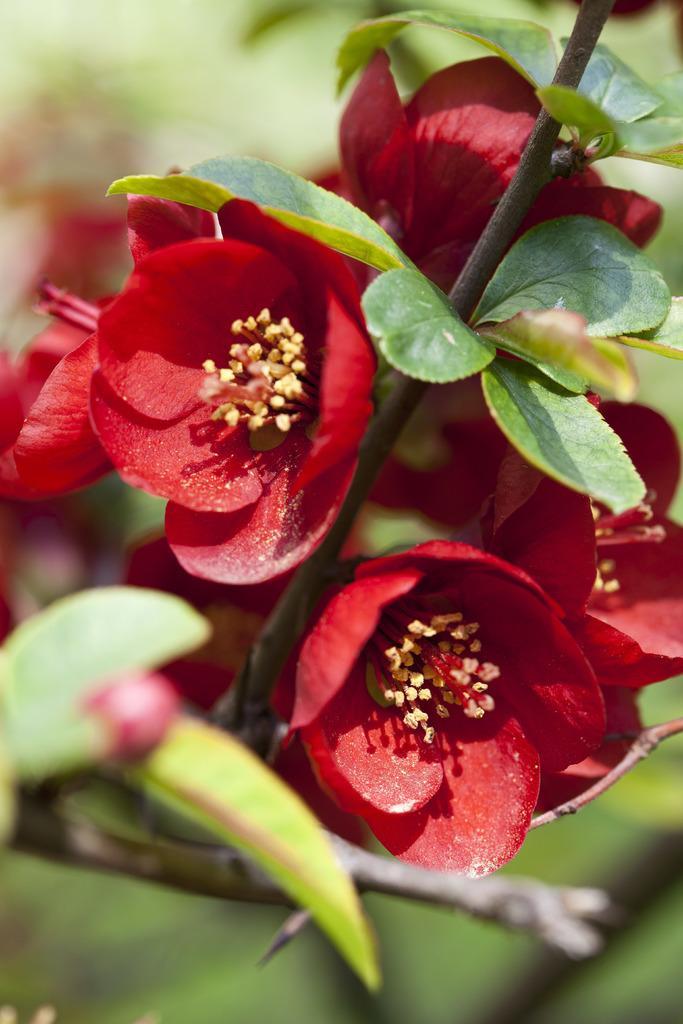Can you describe this image briefly? In this image in the front there are flowers and there are leaves and the background is blurry. 